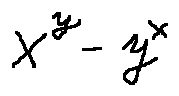<formula> <loc_0><loc_0><loc_500><loc_500>x ^ { y } - y ^ { x }</formula> 